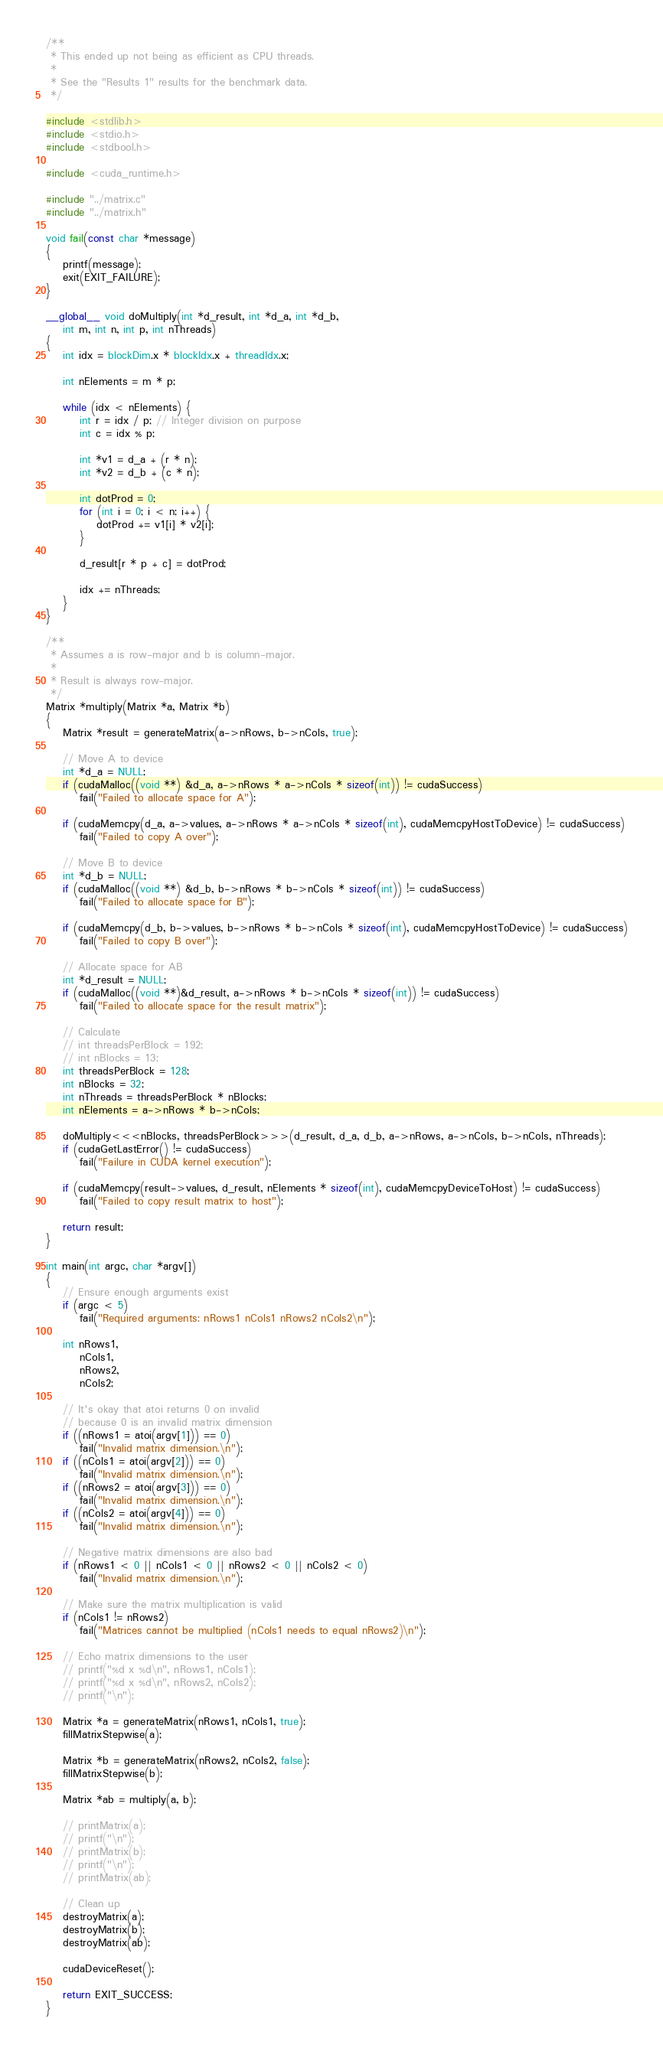<code> <loc_0><loc_0><loc_500><loc_500><_Cuda_>/**
 * This ended up not being as efficient as CPU threads.
 * 
 * See the "Results 1" results for the benchmark data.
 */

#include <stdlib.h>
#include <stdio.h>
#include <stdbool.h>

#include <cuda_runtime.h>

#include "../matrix.c"
#include "../matrix.h"

void fail(const char *message)
{
    printf(message);
    exit(EXIT_FAILURE);
}

__global__ void doMultiply(int *d_result, int *d_a, int *d_b, 
    int m, int n, int p, int nThreads)
{
    int idx = blockDim.x * blockIdx.x + threadIdx.x;

    int nElements = m * p;

    while (idx < nElements) {
        int r = idx / p; // Integer division on purpose
        int c = idx % p;

        int *v1 = d_a + (r * n);
        int *v2 = d_b + (c * n);

        int dotProd = 0;
        for (int i = 0; i < n; i++) {
            dotProd += v1[i] * v2[i];
        }

        d_result[r * p + c] = dotProd;

        idx += nThreads;
    }
}

/**
 * Assumes a is row-major and b is column-major.
 * 
 * Result is always row-major.
 */
Matrix *multiply(Matrix *a, Matrix *b)
{
    Matrix *result = generateMatrix(a->nRows, b->nCols, true);

    // Move A to device
    int *d_a = NULL;
    if (cudaMalloc((void **) &d_a, a->nRows * a->nCols * sizeof(int)) != cudaSuccess)
        fail("Failed to allocate space for A");
        
    if (cudaMemcpy(d_a, a->values, a->nRows * a->nCols * sizeof(int), cudaMemcpyHostToDevice) != cudaSuccess)
        fail("Failed to copy A over");

    // Move B to device
    int *d_b = NULL;
    if (cudaMalloc((void **) &d_b, b->nRows * b->nCols * sizeof(int)) != cudaSuccess)
        fail("Failed to allocate space for B");
    
    if (cudaMemcpy(d_b, b->values, b->nRows * b->nCols * sizeof(int), cudaMemcpyHostToDevice) != cudaSuccess)
        fail("Failed to copy B over");

    // Allocate space for AB
    int *d_result = NULL;
    if (cudaMalloc((void **)&d_result, a->nRows * b->nCols * sizeof(int)) != cudaSuccess)
        fail("Failed to allocate space for the result matrix");

    // Calculate
    // int threadsPerBlock = 192;
    // int nBlocks = 13;
    int threadsPerBlock = 128;
    int nBlocks = 32;
    int nThreads = threadsPerBlock * nBlocks;
    int nElements = a->nRows * b->nCols;
    
    doMultiply<<<nBlocks, threadsPerBlock>>>(d_result, d_a, d_b, a->nRows, a->nCols, b->nCols, nThreads);
    if (cudaGetLastError() != cudaSuccess)
        fail("Failure in CUDA kernel execution");
    
    if (cudaMemcpy(result->values, d_result, nElements * sizeof(int), cudaMemcpyDeviceToHost) != cudaSuccess)
        fail("Failed to copy result matrix to host");

    return result;
}

int main(int argc, char *argv[])
{
    // Ensure enough arguments exist
    if (argc < 5)
        fail("Required arguments: nRows1 nCols1 nRows2 nCols2\n");

    int nRows1,
        nCols1,
        nRows2,
        nCols2;

    // It's okay that atoi returns 0 on invalid
    // because 0 is an invalid matrix dimension
    if ((nRows1 = atoi(argv[1])) == 0)
        fail("Invalid matrix dimension.\n");
    if ((nCols1 = atoi(argv[2])) == 0)
        fail("Invalid matrix dimension.\n");
    if ((nRows2 = atoi(argv[3])) == 0)
        fail("Invalid matrix dimension.\n");
    if ((nCols2 = atoi(argv[4])) == 0)
        fail("Invalid matrix dimension.\n");

    // Negative matrix dimensions are also bad
    if (nRows1 < 0 || nCols1 < 0 || nRows2 < 0 || nCols2 < 0)
        fail("Invalid matrix dimension.\n");
    
    // Make sure the matrix multiplication is valid
    if (nCols1 != nRows2)
        fail("Matrices cannot be multiplied (nCols1 needs to equal nRows2)\n");

    // Echo matrix dimensions to the user
    // printf("%d x %d\n", nRows1, nCols1);
    // printf("%d x %d\n", nRows2, nCols2);
    // printf("\n");

    Matrix *a = generateMatrix(nRows1, nCols1, true);
    fillMatrixStepwise(a);
    
    Matrix *b = generateMatrix(nRows2, nCols2, false);
    fillMatrixStepwise(b);

    Matrix *ab = multiply(a, b);

    // printMatrix(a);
    // printf("\n");
    // printMatrix(b);
    // printf("\n");
    // printMatrix(ab);

    // Clean up
    destroyMatrix(a);
    destroyMatrix(b);
    destroyMatrix(ab);
    
    cudaDeviceReset();

    return EXIT_SUCCESS;
}
</code> 